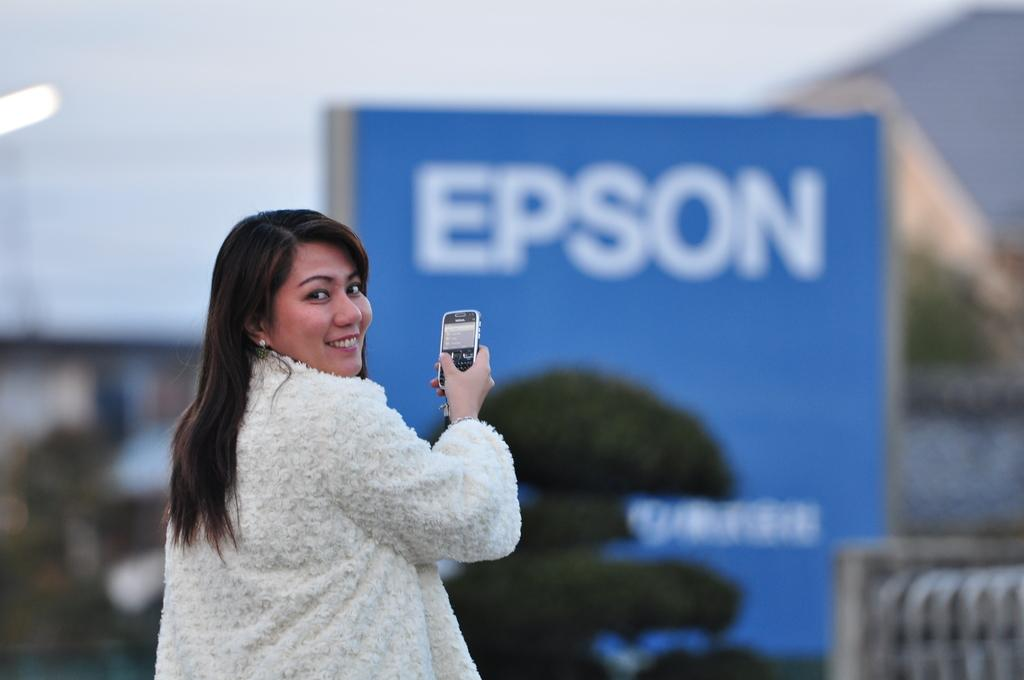Who is present in the image? There is a woman in the image. What is the woman doing in the image? The woman is standing in the image. What object is the woman holding in the image? The woman is holding a mobile phone in the image. What can be seen in the background of the image? There is a blue poster and trees in the background of the image. What type of mint is growing on the woman's shoes in the image? There is no mention of shoes or mint in the image, so we cannot answer this question. 